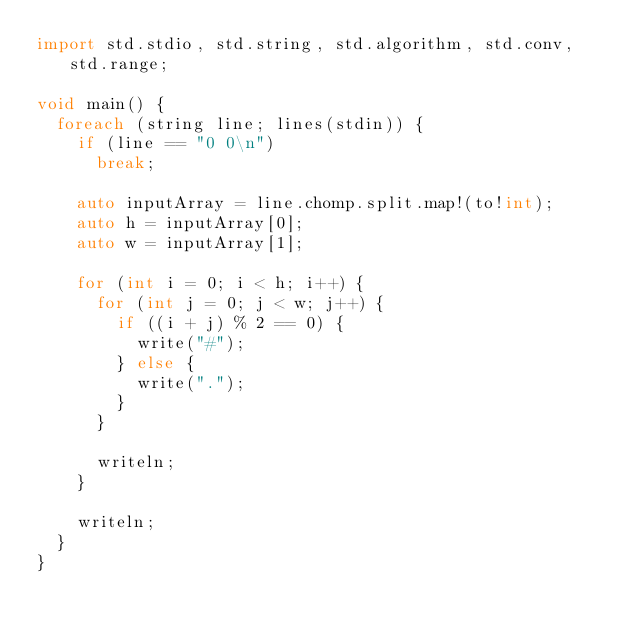<code> <loc_0><loc_0><loc_500><loc_500><_D_>import std.stdio, std.string, std.algorithm, std.conv, std.range;

void main() {
  foreach (string line; lines(stdin)) {
    if (line == "0 0\n")
      break;

    auto inputArray = line.chomp.split.map!(to!int);
    auto h = inputArray[0];
    auto w = inputArray[1];

    for (int i = 0; i < h; i++) {
      for (int j = 0; j < w; j++) {
        if ((i + j) % 2 == 0) {
          write("#");
        } else {
          write(".");
        }
      }
      
      writeln;
    }
    
    writeln;
  }
}</code> 